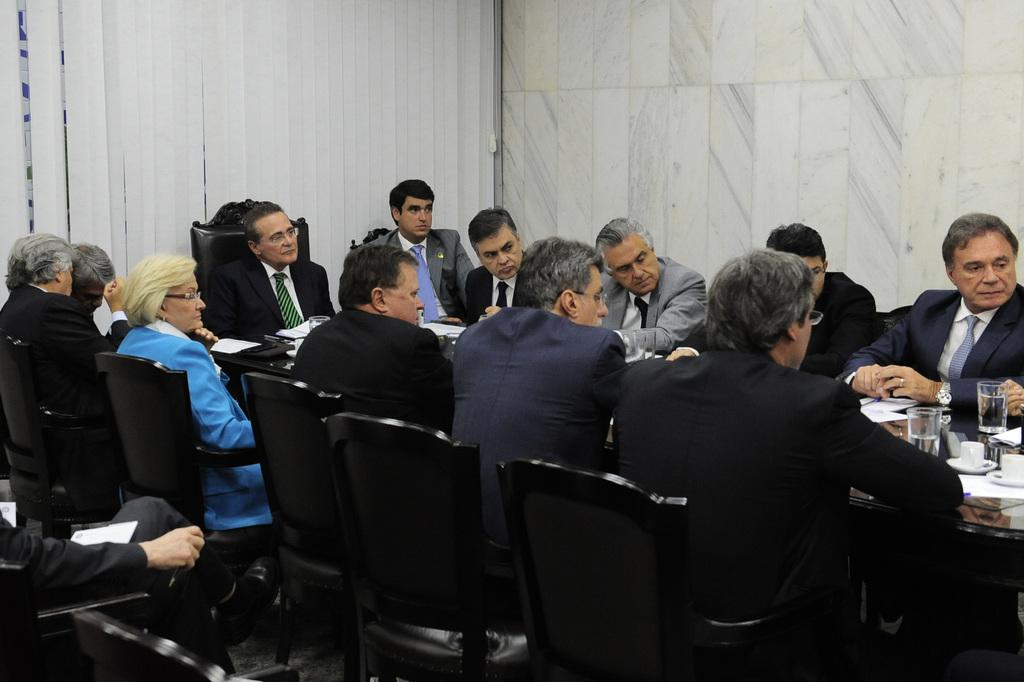How many people are in the image? There is a group of people in the image. What are the people doing in the image? The people are sitting on chairs. Where are the chairs located in relation to the table? The chairs are in front of a table. What types of containers can be seen on the table? There are glasses and cups on the table. What other objects are present on the table? There are other objects on the table. What type of fruit is mentioned in the caption of the image? There is no caption present in the image, and therefore no fruit mentioned. Where is the bed located in the image? There is no bed present in the image. 